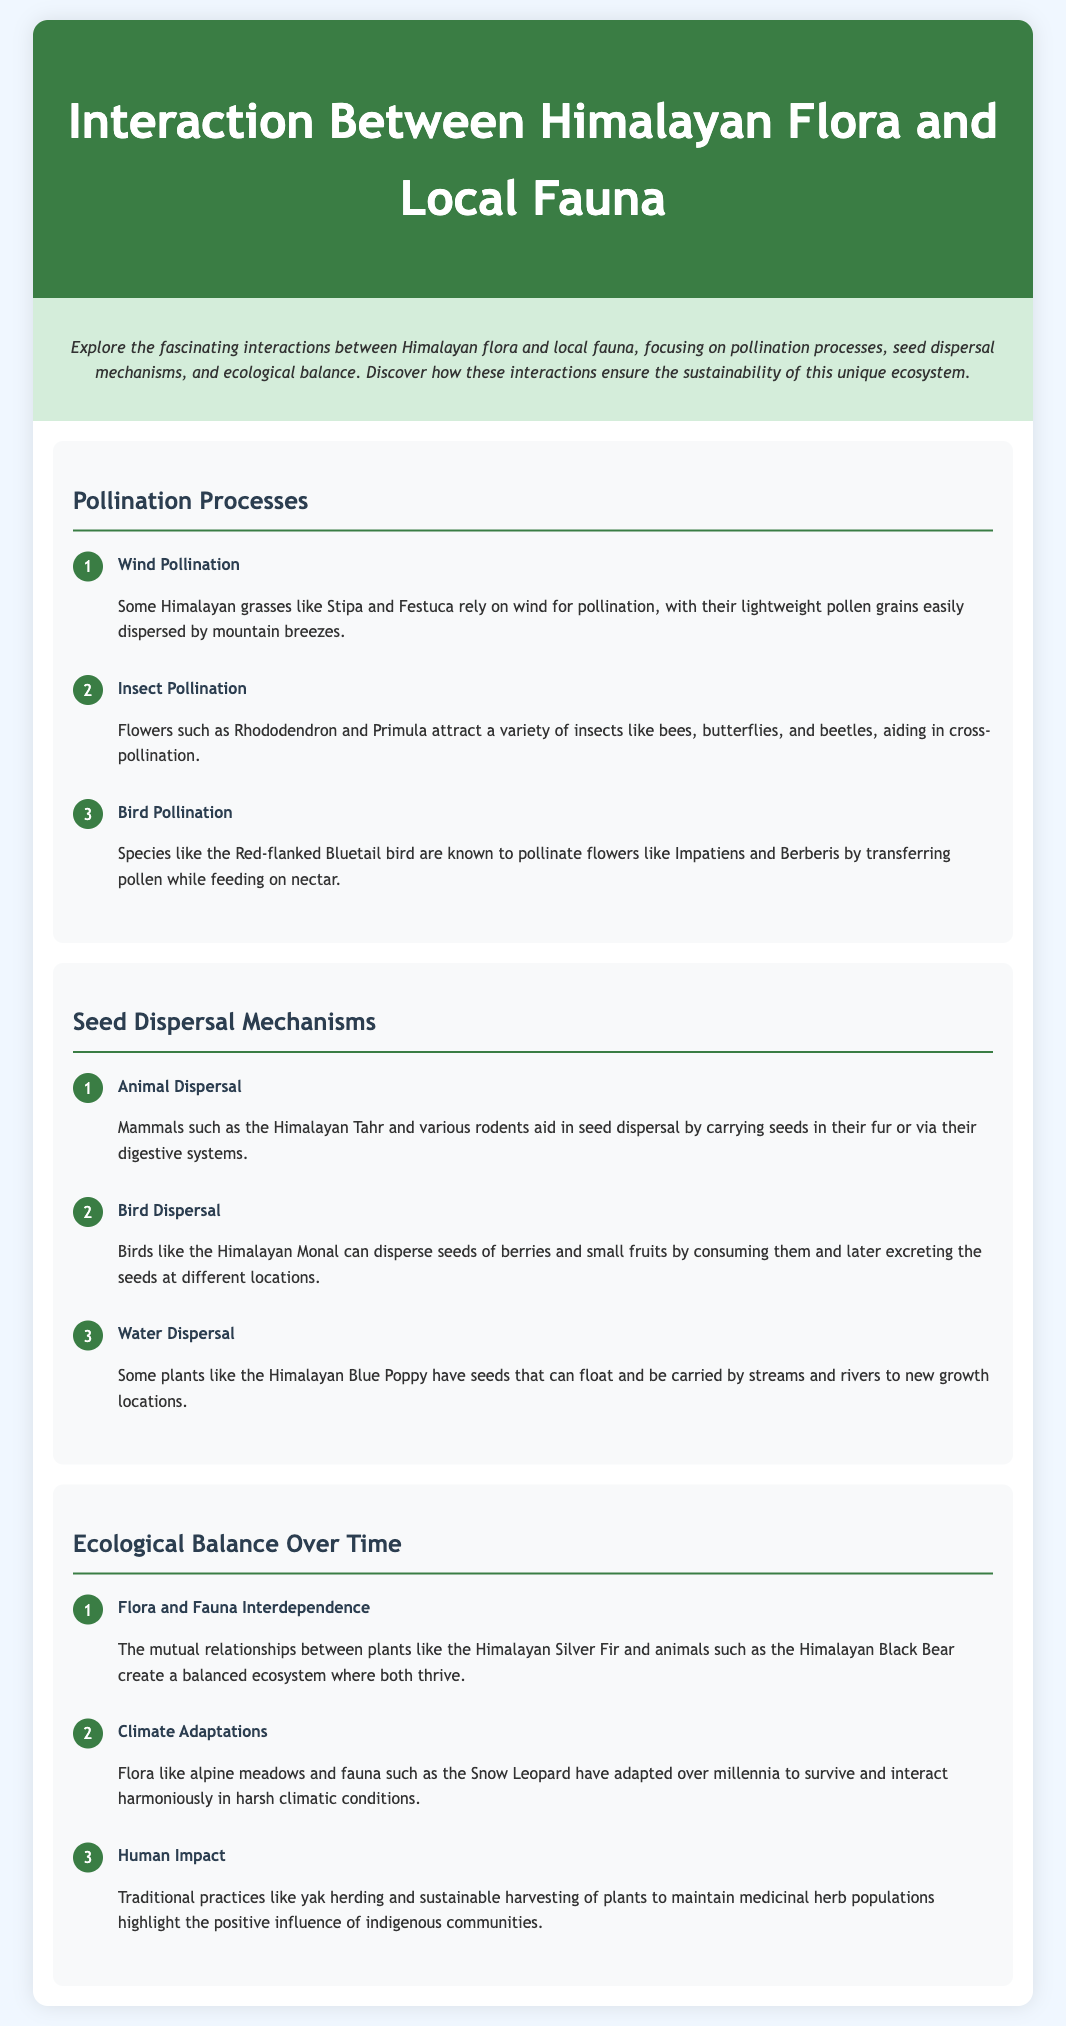What is one method of pollination mentioned? The document mentions multiple methods of pollination, one of which is wind pollination.
Answer: wind pollination Which species is associated with insect pollination? The document specifies that flowers such as Rhododendron attract various insects for pollination.
Answer: Rhododendron How do birds contribute to pollination? The document explains that birds like the Red-flanked Bluetail pollinate flowers while feeding on nectar.
Answer: feeding on nectar Which animal aids in seed dispersal by carrying seeds in its fur? The document states that mammals such as the Himalayan Tahr help disperse seeds by carrying them in their fur.
Answer: Himalayan Tahr What is a seed dispersal method mentioned that involves water? The document describes that some plants, like the Himalayan Blue Poppy, have seeds that can float and be carried by water.
Answer: float What is highlighted as the positive influence of indigenous communities? The document points out that traditional practices such as yak herding have a positive influence on maintaining medicinal herb populations.
Answer: yak herding How many steps are included in the pollination processes section? The document lists three specific steps in the pollination processes section.
Answer: three What relationship creates a balanced ecosystem according to the document? The document illustrates that the mutual relationships between plants like the Himalayan Silver Fir and animals like the Himalayan Black Bear create balance.
Answer: mutual relationships What adaptation is mentioned for flora and fauna? The document notes that flora like alpine meadows and fauna such as the Snow Leopard have adapted to survive in harsh conditions.
Answer: adapted to survive 